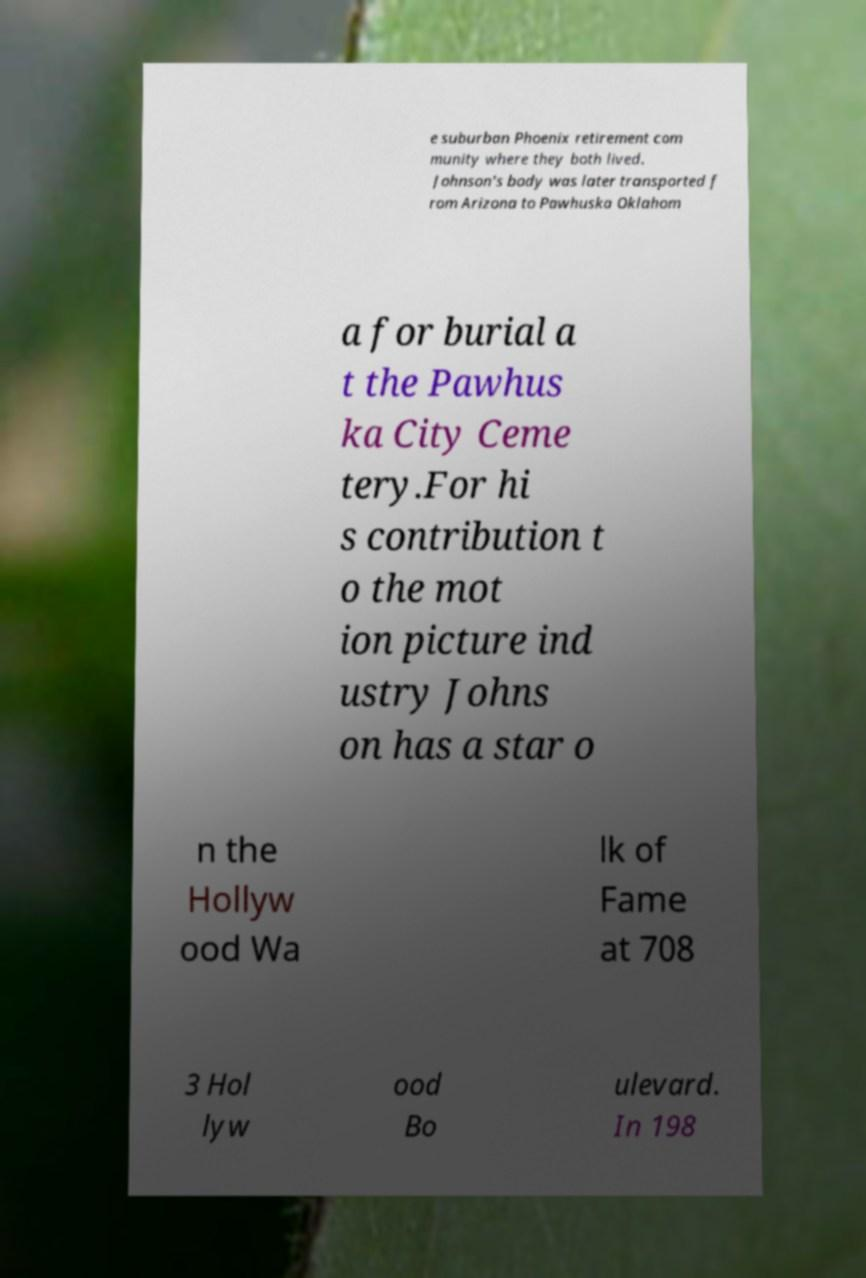Could you assist in decoding the text presented in this image and type it out clearly? e suburban Phoenix retirement com munity where they both lived. Johnson's body was later transported f rom Arizona to Pawhuska Oklahom a for burial a t the Pawhus ka City Ceme tery.For hi s contribution t o the mot ion picture ind ustry Johns on has a star o n the Hollyw ood Wa lk of Fame at 708 3 Hol lyw ood Bo ulevard. In 198 